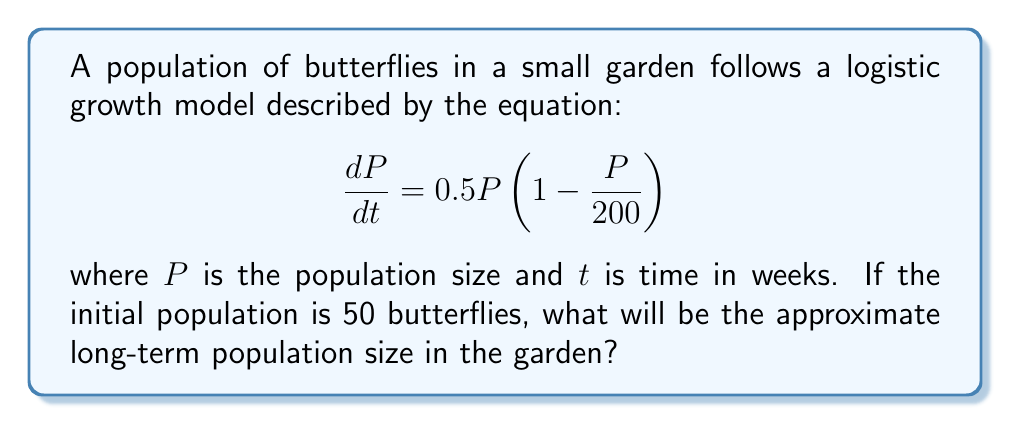Can you solve this math problem? Let's approach this step-by-step:

1) The given equation is a logistic growth model in the form:

   $$\frac{dP}{dt} = rP(1 - \frac{P}{K})$$

   where $r$ is the growth rate and $K$ is the carrying capacity.

2) From our equation, we can identify:
   $r = 0.5$ (growth rate)
   $K = 200$ (carrying capacity)

3) To find the long-term behavior, we need to find the equilibrium points. These occur when $\frac{dP}{dt} = 0$.

4) Setting the equation to zero:

   $$0 = 0.5P(1 - \frac{P}{200})$$

5) Solving this equation:
   - $P = 0$ (trivial solution)
   - $1 - \frac{P}{200} = 0$
     $\frac{P}{200} = 1$
     $P = 200$

6) The non-zero equilibrium point $P = 200$ is stable and attracts all positive initial conditions.

7) Therefore, regardless of the initial population (as long as it's positive), the long-term population will approach the carrying capacity, $K = 200$.

8) The initial population of 50 butterflies is positive, so it will grow towards 200 over time.
Answer: 200 butterflies 